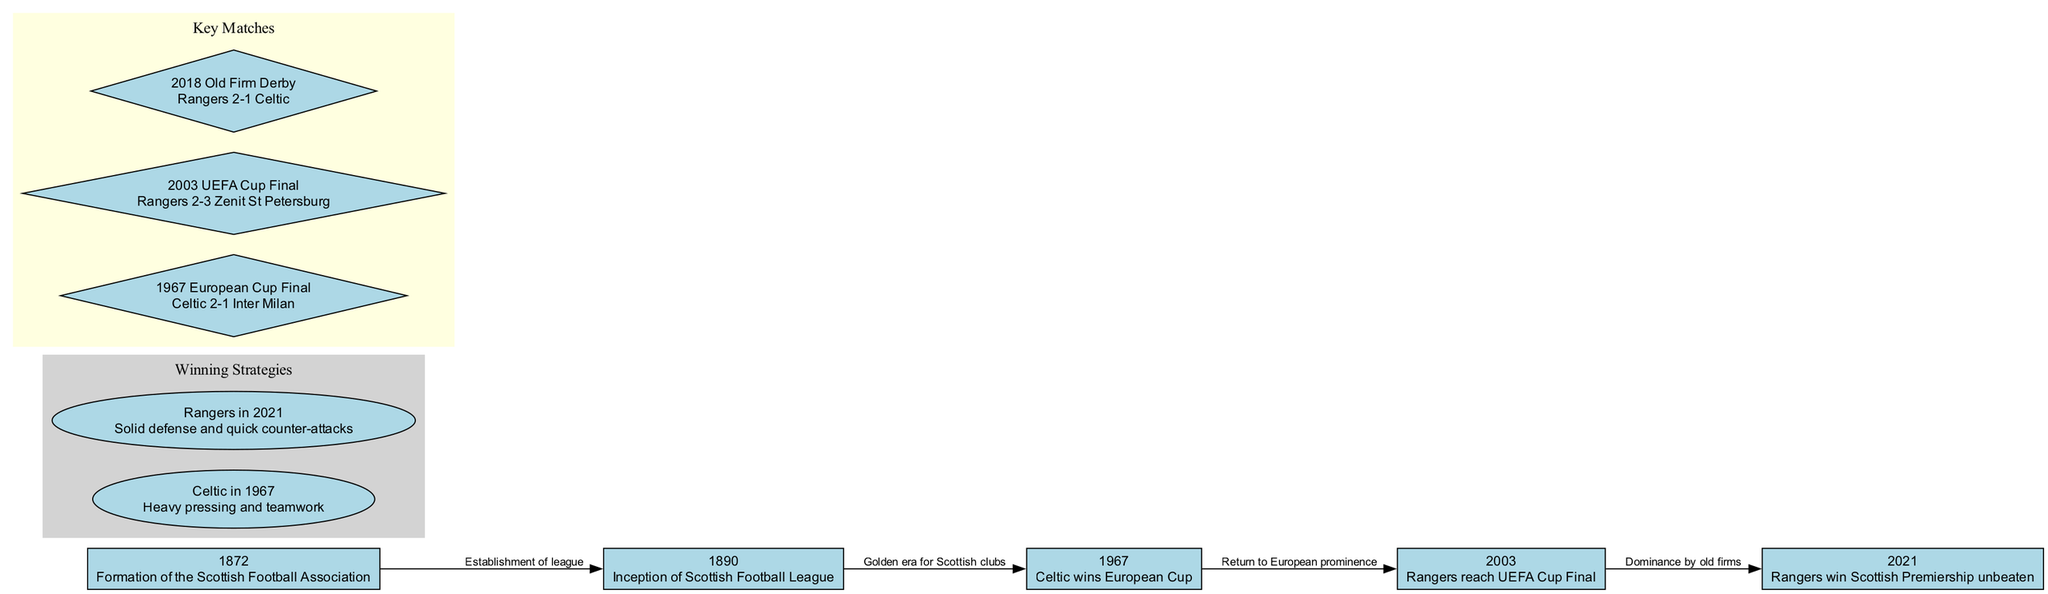What year was the Scottish Football Association formed? The diagram indicates that the formation of the Scottish Football Association occurred in the year 1872, which is explicitly labeled in the node.
Answer: 1872 What significant event took place in 1967? According to the diagram, the key event in 1967 is Celtic winning the European Cup, as stated in the node description for that year.
Answer: Celtic wins European Cup How many nodes are there in the diagram? By counting the nodes listed, there are five nodes in total: the years 1872, 1890, 1967, 2003, and 2021.
Answer: 5 What relationship does the edge from 2003 to 2021 represent? The edge connecting 2003 to 2021 is labeled as "Dominance by old firms," indicating the historical significance of the relationship between these years in Scottish football context.
Answer: Dominance by old firms What winning strategy did Celtic employ in 1967? The diagram details that Celtic's winning strategy in 1967 was characterized by "Heavy pressing and teamwork," explicitly stated under the winning strategies section.
Answer: Heavy pressing and teamwork Which match is listed as the key match in 1967? The diagram specifies that the key match from 1967 is the "1967 European Cup Final," described as Celtic 2-1 Inter Milan.
Answer: 1967 European Cup Final Which team reached the UEFA Cup Final in 2003? Based on the information in the diagram, Rangers is the team that reached the UEFA Cup Final in 2003, as indicated in the node description.
Answer: Rangers What connection is indicated between the formation of the Scottish Football Association and the inception of the Scottish Football League? The edge connecting these two nodes is labeled "Establishment of league," which indicates the cause-and-effect relationship: the formation led to the establishment of the league.
Answer: Establishment of league What winning strategy did Rangers use in 2021? The diagram states that Rangers employed a strategy focused on "Solid defense and quick counter-attacks," which is explicitly mentioned in their strategy description.
Answer: Solid defense and quick counter-attacks 